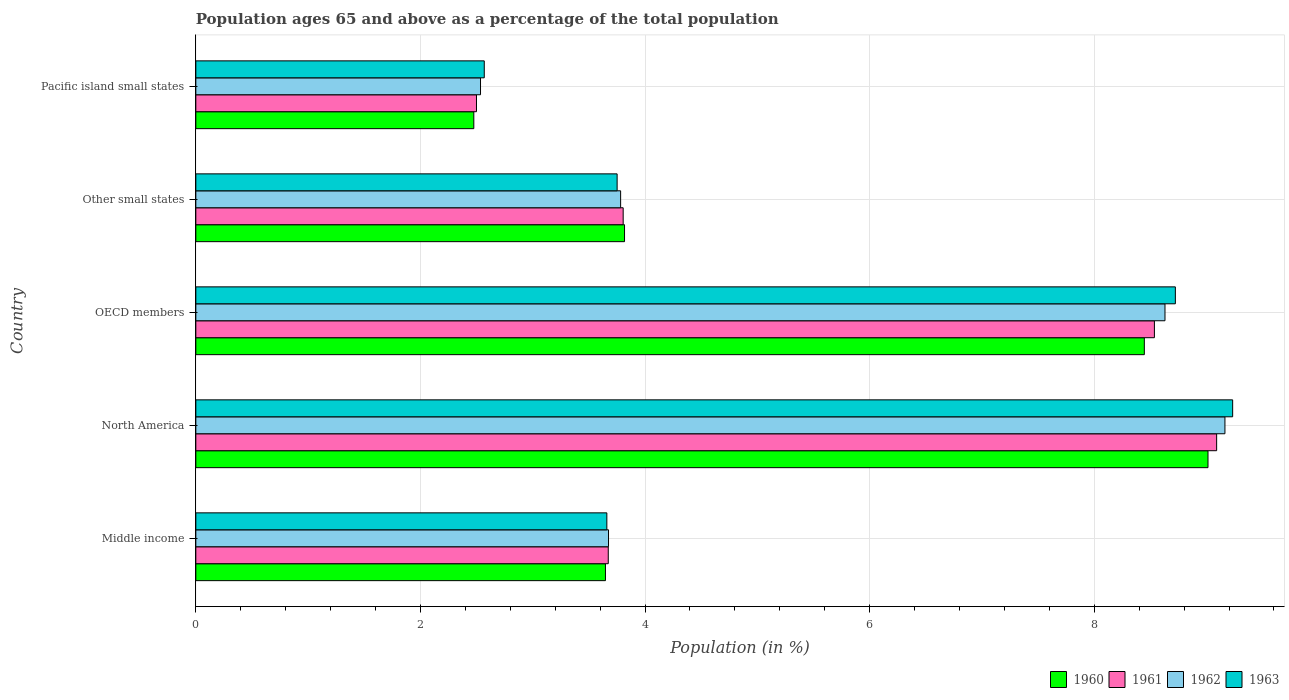How many different coloured bars are there?
Provide a short and direct response. 4. How many groups of bars are there?
Give a very brief answer. 5. How many bars are there on the 5th tick from the top?
Your answer should be compact. 4. What is the label of the 1st group of bars from the top?
Offer a very short reply. Pacific island small states. In how many cases, is the number of bars for a given country not equal to the number of legend labels?
Provide a succinct answer. 0. What is the percentage of the population ages 65 and above in 1962 in North America?
Your answer should be compact. 9.16. Across all countries, what is the maximum percentage of the population ages 65 and above in 1962?
Your answer should be compact. 9.16. Across all countries, what is the minimum percentage of the population ages 65 and above in 1963?
Offer a terse response. 2.57. In which country was the percentage of the population ages 65 and above in 1960 minimum?
Offer a terse response. Pacific island small states. What is the total percentage of the population ages 65 and above in 1961 in the graph?
Your answer should be compact. 27.6. What is the difference between the percentage of the population ages 65 and above in 1961 in Middle income and that in Pacific island small states?
Give a very brief answer. 1.17. What is the difference between the percentage of the population ages 65 and above in 1961 in Pacific island small states and the percentage of the population ages 65 and above in 1963 in Middle income?
Your answer should be compact. -1.16. What is the average percentage of the population ages 65 and above in 1962 per country?
Offer a very short reply. 5.56. What is the difference between the percentage of the population ages 65 and above in 1961 and percentage of the population ages 65 and above in 1960 in North America?
Your answer should be very brief. 0.08. In how many countries, is the percentage of the population ages 65 and above in 1962 greater than 8.4 ?
Provide a succinct answer. 2. What is the ratio of the percentage of the population ages 65 and above in 1961 in OECD members to that in Pacific island small states?
Offer a terse response. 3.42. Is the difference between the percentage of the population ages 65 and above in 1961 in OECD members and Pacific island small states greater than the difference between the percentage of the population ages 65 and above in 1960 in OECD members and Pacific island small states?
Ensure brevity in your answer.  Yes. What is the difference between the highest and the second highest percentage of the population ages 65 and above in 1962?
Ensure brevity in your answer.  0.53. What is the difference between the highest and the lowest percentage of the population ages 65 and above in 1961?
Make the answer very short. 6.59. In how many countries, is the percentage of the population ages 65 and above in 1960 greater than the average percentage of the population ages 65 and above in 1960 taken over all countries?
Offer a very short reply. 2. Is the sum of the percentage of the population ages 65 and above in 1960 in Middle income and North America greater than the maximum percentage of the population ages 65 and above in 1962 across all countries?
Provide a short and direct response. Yes. Does the graph contain any zero values?
Keep it short and to the point. No. How many legend labels are there?
Make the answer very short. 4. What is the title of the graph?
Offer a terse response. Population ages 65 and above as a percentage of the total population. What is the label or title of the Y-axis?
Your response must be concise. Country. What is the Population (in %) of 1960 in Middle income?
Make the answer very short. 3.65. What is the Population (in %) of 1961 in Middle income?
Provide a succinct answer. 3.67. What is the Population (in %) in 1962 in Middle income?
Offer a terse response. 3.67. What is the Population (in %) in 1963 in Middle income?
Make the answer very short. 3.66. What is the Population (in %) in 1960 in North America?
Your response must be concise. 9.01. What is the Population (in %) in 1961 in North America?
Provide a succinct answer. 9.09. What is the Population (in %) in 1962 in North America?
Ensure brevity in your answer.  9.16. What is the Population (in %) in 1963 in North America?
Offer a very short reply. 9.23. What is the Population (in %) of 1960 in OECD members?
Offer a terse response. 8.45. What is the Population (in %) in 1961 in OECD members?
Your answer should be very brief. 8.54. What is the Population (in %) in 1962 in OECD members?
Your response must be concise. 8.63. What is the Population (in %) in 1963 in OECD members?
Your answer should be very brief. 8.72. What is the Population (in %) of 1960 in Other small states?
Offer a very short reply. 3.82. What is the Population (in %) of 1961 in Other small states?
Your answer should be compact. 3.81. What is the Population (in %) of 1962 in Other small states?
Keep it short and to the point. 3.78. What is the Population (in %) in 1963 in Other small states?
Provide a succinct answer. 3.75. What is the Population (in %) of 1960 in Pacific island small states?
Make the answer very short. 2.48. What is the Population (in %) in 1961 in Pacific island small states?
Offer a terse response. 2.5. What is the Population (in %) of 1962 in Pacific island small states?
Make the answer very short. 2.54. What is the Population (in %) of 1963 in Pacific island small states?
Your answer should be very brief. 2.57. Across all countries, what is the maximum Population (in %) of 1960?
Offer a very short reply. 9.01. Across all countries, what is the maximum Population (in %) in 1961?
Keep it short and to the point. 9.09. Across all countries, what is the maximum Population (in %) of 1962?
Keep it short and to the point. 9.16. Across all countries, what is the maximum Population (in %) of 1963?
Give a very brief answer. 9.23. Across all countries, what is the minimum Population (in %) in 1960?
Make the answer very short. 2.48. Across all countries, what is the minimum Population (in %) in 1961?
Make the answer very short. 2.5. Across all countries, what is the minimum Population (in %) in 1962?
Ensure brevity in your answer.  2.54. Across all countries, what is the minimum Population (in %) in 1963?
Your response must be concise. 2.57. What is the total Population (in %) of 1960 in the graph?
Your answer should be compact. 27.4. What is the total Population (in %) in 1961 in the graph?
Provide a short and direct response. 27.6. What is the total Population (in %) in 1962 in the graph?
Provide a succinct answer. 27.79. What is the total Population (in %) in 1963 in the graph?
Provide a short and direct response. 27.93. What is the difference between the Population (in %) of 1960 in Middle income and that in North America?
Ensure brevity in your answer.  -5.37. What is the difference between the Population (in %) in 1961 in Middle income and that in North America?
Your answer should be very brief. -5.42. What is the difference between the Population (in %) in 1962 in Middle income and that in North America?
Provide a short and direct response. -5.49. What is the difference between the Population (in %) in 1963 in Middle income and that in North America?
Keep it short and to the point. -5.57. What is the difference between the Population (in %) of 1960 in Middle income and that in OECD members?
Your response must be concise. -4.8. What is the difference between the Population (in %) in 1961 in Middle income and that in OECD members?
Offer a terse response. -4.86. What is the difference between the Population (in %) in 1962 in Middle income and that in OECD members?
Your response must be concise. -4.96. What is the difference between the Population (in %) of 1963 in Middle income and that in OECD members?
Provide a short and direct response. -5.06. What is the difference between the Population (in %) in 1960 in Middle income and that in Other small states?
Your response must be concise. -0.17. What is the difference between the Population (in %) in 1961 in Middle income and that in Other small states?
Offer a very short reply. -0.13. What is the difference between the Population (in %) of 1962 in Middle income and that in Other small states?
Your response must be concise. -0.11. What is the difference between the Population (in %) of 1963 in Middle income and that in Other small states?
Your answer should be compact. -0.09. What is the difference between the Population (in %) in 1960 in Middle income and that in Pacific island small states?
Give a very brief answer. 1.17. What is the difference between the Population (in %) of 1961 in Middle income and that in Pacific island small states?
Provide a short and direct response. 1.17. What is the difference between the Population (in %) of 1962 in Middle income and that in Pacific island small states?
Offer a very short reply. 1.14. What is the difference between the Population (in %) of 1963 in Middle income and that in Pacific island small states?
Make the answer very short. 1.09. What is the difference between the Population (in %) of 1960 in North America and that in OECD members?
Ensure brevity in your answer.  0.57. What is the difference between the Population (in %) of 1961 in North America and that in OECD members?
Offer a very short reply. 0.55. What is the difference between the Population (in %) of 1962 in North America and that in OECD members?
Give a very brief answer. 0.53. What is the difference between the Population (in %) in 1963 in North America and that in OECD members?
Your answer should be very brief. 0.51. What is the difference between the Population (in %) in 1960 in North America and that in Other small states?
Give a very brief answer. 5.2. What is the difference between the Population (in %) of 1961 in North America and that in Other small states?
Your answer should be compact. 5.28. What is the difference between the Population (in %) in 1962 in North America and that in Other small states?
Provide a succinct answer. 5.38. What is the difference between the Population (in %) in 1963 in North America and that in Other small states?
Ensure brevity in your answer.  5.48. What is the difference between the Population (in %) in 1960 in North America and that in Pacific island small states?
Provide a short and direct response. 6.54. What is the difference between the Population (in %) of 1961 in North America and that in Pacific island small states?
Make the answer very short. 6.59. What is the difference between the Population (in %) of 1962 in North America and that in Pacific island small states?
Provide a succinct answer. 6.63. What is the difference between the Population (in %) in 1963 in North America and that in Pacific island small states?
Your answer should be very brief. 6.66. What is the difference between the Population (in %) in 1960 in OECD members and that in Other small states?
Keep it short and to the point. 4.63. What is the difference between the Population (in %) in 1961 in OECD members and that in Other small states?
Make the answer very short. 4.73. What is the difference between the Population (in %) of 1962 in OECD members and that in Other small states?
Make the answer very short. 4.85. What is the difference between the Population (in %) of 1963 in OECD members and that in Other small states?
Provide a short and direct response. 4.97. What is the difference between the Population (in %) in 1960 in OECD members and that in Pacific island small states?
Your response must be concise. 5.97. What is the difference between the Population (in %) of 1961 in OECD members and that in Pacific island small states?
Ensure brevity in your answer.  6.04. What is the difference between the Population (in %) in 1962 in OECD members and that in Pacific island small states?
Your answer should be very brief. 6.09. What is the difference between the Population (in %) in 1963 in OECD members and that in Pacific island small states?
Make the answer very short. 6.15. What is the difference between the Population (in %) in 1960 in Other small states and that in Pacific island small states?
Keep it short and to the point. 1.34. What is the difference between the Population (in %) of 1961 in Other small states and that in Pacific island small states?
Provide a succinct answer. 1.31. What is the difference between the Population (in %) of 1962 in Other small states and that in Pacific island small states?
Keep it short and to the point. 1.25. What is the difference between the Population (in %) in 1963 in Other small states and that in Pacific island small states?
Ensure brevity in your answer.  1.18. What is the difference between the Population (in %) in 1960 in Middle income and the Population (in %) in 1961 in North America?
Keep it short and to the point. -5.44. What is the difference between the Population (in %) of 1960 in Middle income and the Population (in %) of 1962 in North America?
Keep it short and to the point. -5.52. What is the difference between the Population (in %) of 1960 in Middle income and the Population (in %) of 1963 in North America?
Your response must be concise. -5.58. What is the difference between the Population (in %) in 1961 in Middle income and the Population (in %) in 1962 in North America?
Provide a succinct answer. -5.49. What is the difference between the Population (in %) of 1961 in Middle income and the Population (in %) of 1963 in North America?
Your answer should be compact. -5.56. What is the difference between the Population (in %) of 1962 in Middle income and the Population (in %) of 1963 in North America?
Your answer should be compact. -5.56. What is the difference between the Population (in %) of 1960 in Middle income and the Population (in %) of 1961 in OECD members?
Ensure brevity in your answer.  -4.89. What is the difference between the Population (in %) of 1960 in Middle income and the Population (in %) of 1962 in OECD members?
Give a very brief answer. -4.98. What is the difference between the Population (in %) of 1960 in Middle income and the Population (in %) of 1963 in OECD members?
Offer a terse response. -5.07. What is the difference between the Population (in %) of 1961 in Middle income and the Population (in %) of 1962 in OECD members?
Your answer should be compact. -4.96. What is the difference between the Population (in %) in 1961 in Middle income and the Population (in %) in 1963 in OECD members?
Offer a terse response. -5.05. What is the difference between the Population (in %) of 1962 in Middle income and the Population (in %) of 1963 in OECD members?
Provide a short and direct response. -5.05. What is the difference between the Population (in %) of 1960 in Middle income and the Population (in %) of 1961 in Other small states?
Your answer should be compact. -0.16. What is the difference between the Population (in %) in 1960 in Middle income and the Population (in %) in 1962 in Other small states?
Provide a short and direct response. -0.14. What is the difference between the Population (in %) in 1960 in Middle income and the Population (in %) in 1963 in Other small states?
Offer a very short reply. -0.1. What is the difference between the Population (in %) in 1961 in Middle income and the Population (in %) in 1962 in Other small states?
Offer a terse response. -0.11. What is the difference between the Population (in %) in 1961 in Middle income and the Population (in %) in 1963 in Other small states?
Provide a short and direct response. -0.08. What is the difference between the Population (in %) of 1962 in Middle income and the Population (in %) of 1963 in Other small states?
Your answer should be compact. -0.08. What is the difference between the Population (in %) in 1960 in Middle income and the Population (in %) in 1961 in Pacific island small states?
Make the answer very short. 1.15. What is the difference between the Population (in %) in 1960 in Middle income and the Population (in %) in 1962 in Pacific island small states?
Your answer should be very brief. 1.11. What is the difference between the Population (in %) of 1960 in Middle income and the Population (in %) of 1963 in Pacific island small states?
Ensure brevity in your answer.  1.08. What is the difference between the Population (in %) of 1961 in Middle income and the Population (in %) of 1962 in Pacific island small states?
Offer a very short reply. 1.14. What is the difference between the Population (in %) of 1961 in Middle income and the Population (in %) of 1963 in Pacific island small states?
Provide a succinct answer. 1.1. What is the difference between the Population (in %) in 1962 in Middle income and the Population (in %) in 1963 in Pacific island small states?
Your answer should be compact. 1.11. What is the difference between the Population (in %) of 1960 in North America and the Population (in %) of 1961 in OECD members?
Ensure brevity in your answer.  0.48. What is the difference between the Population (in %) of 1960 in North America and the Population (in %) of 1962 in OECD members?
Your response must be concise. 0.38. What is the difference between the Population (in %) in 1960 in North America and the Population (in %) in 1963 in OECD members?
Your answer should be very brief. 0.29. What is the difference between the Population (in %) in 1961 in North America and the Population (in %) in 1962 in OECD members?
Provide a succinct answer. 0.46. What is the difference between the Population (in %) in 1961 in North America and the Population (in %) in 1963 in OECD members?
Offer a very short reply. 0.37. What is the difference between the Population (in %) in 1962 in North America and the Population (in %) in 1963 in OECD members?
Your answer should be compact. 0.44. What is the difference between the Population (in %) in 1960 in North America and the Population (in %) in 1961 in Other small states?
Give a very brief answer. 5.21. What is the difference between the Population (in %) in 1960 in North America and the Population (in %) in 1962 in Other small states?
Offer a terse response. 5.23. What is the difference between the Population (in %) of 1960 in North America and the Population (in %) of 1963 in Other small states?
Keep it short and to the point. 5.26. What is the difference between the Population (in %) in 1961 in North America and the Population (in %) in 1962 in Other small states?
Make the answer very short. 5.31. What is the difference between the Population (in %) of 1961 in North America and the Population (in %) of 1963 in Other small states?
Give a very brief answer. 5.34. What is the difference between the Population (in %) in 1962 in North America and the Population (in %) in 1963 in Other small states?
Your answer should be very brief. 5.41. What is the difference between the Population (in %) in 1960 in North America and the Population (in %) in 1961 in Pacific island small states?
Keep it short and to the point. 6.51. What is the difference between the Population (in %) in 1960 in North America and the Population (in %) in 1962 in Pacific island small states?
Your answer should be compact. 6.48. What is the difference between the Population (in %) of 1960 in North America and the Population (in %) of 1963 in Pacific island small states?
Provide a short and direct response. 6.44. What is the difference between the Population (in %) in 1961 in North America and the Population (in %) in 1962 in Pacific island small states?
Keep it short and to the point. 6.55. What is the difference between the Population (in %) in 1961 in North America and the Population (in %) in 1963 in Pacific island small states?
Provide a succinct answer. 6.52. What is the difference between the Population (in %) in 1962 in North America and the Population (in %) in 1963 in Pacific island small states?
Provide a short and direct response. 6.6. What is the difference between the Population (in %) of 1960 in OECD members and the Population (in %) of 1961 in Other small states?
Give a very brief answer. 4.64. What is the difference between the Population (in %) of 1960 in OECD members and the Population (in %) of 1962 in Other small states?
Keep it short and to the point. 4.66. What is the difference between the Population (in %) of 1960 in OECD members and the Population (in %) of 1963 in Other small states?
Offer a very short reply. 4.69. What is the difference between the Population (in %) of 1961 in OECD members and the Population (in %) of 1962 in Other small states?
Your response must be concise. 4.75. What is the difference between the Population (in %) of 1961 in OECD members and the Population (in %) of 1963 in Other small states?
Provide a short and direct response. 4.78. What is the difference between the Population (in %) in 1962 in OECD members and the Population (in %) in 1963 in Other small states?
Make the answer very short. 4.88. What is the difference between the Population (in %) in 1960 in OECD members and the Population (in %) in 1961 in Pacific island small states?
Offer a very short reply. 5.95. What is the difference between the Population (in %) in 1960 in OECD members and the Population (in %) in 1962 in Pacific island small states?
Your response must be concise. 5.91. What is the difference between the Population (in %) of 1960 in OECD members and the Population (in %) of 1963 in Pacific island small states?
Ensure brevity in your answer.  5.88. What is the difference between the Population (in %) in 1961 in OECD members and the Population (in %) in 1962 in Pacific island small states?
Provide a short and direct response. 6. What is the difference between the Population (in %) of 1961 in OECD members and the Population (in %) of 1963 in Pacific island small states?
Offer a terse response. 5.97. What is the difference between the Population (in %) in 1962 in OECD members and the Population (in %) in 1963 in Pacific island small states?
Your answer should be very brief. 6.06. What is the difference between the Population (in %) in 1960 in Other small states and the Population (in %) in 1961 in Pacific island small states?
Offer a terse response. 1.32. What is the difference between the Population (in %) of 1960 in Other small states and the Population (in %) of 1962 in Pacific island small states?
Ensure brevity in your answer.  1.28. What is the difference between the Population (in %) in 1960 in Other small states and the Population (in %) in 1963 in Pacific island small states?
Offer a very short reply. 1.25. What is the difference between the Population (in %) in 1961 in Other small states and the Population (in %) in 1962 in Pacific island small states?
Make the answer very short. 1.27. What is the difference between the Population (in %) in 1961 in Other small states and the Population (in %) in 1963 in Pacific island small states?
Offer a very short reply. 1.24. What is the difference between the Population (in %) in 1962 in Other small states and the Population (in %) in 1963 in Pacific island small states?
Ensure brevity in your answer.  1.21. What is the average Population (in %) of 1960 per country?
Provide a succinct answer. 5.48. What is the average Population (in %) of 1961 per country?
Keep it short and to the point. 5.52. What is the average Population (in %) of 1962 per country?
Your answer should be compact. 5.56. What is the average Population (in %) in 1963 per country?
Provide a succinct answer. 5.59. What is the difference between the Population (in %) of 1960 and Population (in %) of 1961 in Middle income?
Make the answer very short. -0.03. What is the difference between the Population (in %) of 1960 and Population (in %) of 1962 in Middle income?
Offer a terse response. -0.03. What is the difference between the Population (in %) in 1960 and Population (in %) in 1963 in Middle income?
Ensure brevity in your answer.  -0.01. What is the difference between the Population (in %) in 1961 and Population (in %) in 1962 in Middle income?
Offer a very short reply. -0. What is the difference between the Population (in %) in 1961 and Population (in %) in 1963 in Middle income?
Your response must be concise. 0.01. What is the difference between the Population (in %) in 1962 and Population (in %) in 1963 in Middle income?
Give a very brief answer. 0.01. What is the difference between the Population (in %) in 1960 and Population (in %) in 1961 in North America?
Give a very brief answer. -0.08. What is the difference between the Population (in %) of 1960 and Population (in %) of 1962 in North America?
Make the answer very short. -0.15. What is the difference between the Population (in %) in 1960 and Population (in %) in 1963 in North America?
Make the answer very short. -0.22. What is the difference between the Population (in %) of 1961 and Population (in %) of 1962 in North America?
Offer a very short reply. -0.07. What is the difference between the Population (in %) in 1961 and Population (in %) in 1963 in North America?
Give a very brief answer. -0.14. What is the difference between the Population (in %) of 1962 and Population (in %) of 1963 in North America?
Provide a succinct answer. -0.07. What is the difference between the Population (in %) of 1960 and Population (in %) of 1961 in OECD members?
Your answer should be very brief. -0.09. What is the difference between the Population (in %) in 1960 and Population (in %) in 1962 in OECD members?
Make the answer very short. -0.18. What is the difference between the Population (in %) of 1960 and Population (in %) of 1963 in OECD members?
Provide a short and direct response. -0.28. What is the difference between the Population (in %) of 1961 and Population (in %) of 1962 in OECD members?
Your answer should be compact. -0.09. What is the difference between the Population (in %) in 1961 and Population (in %) in 1963 in OECD members?
Make the answer very short. -0.19. What is the difference between the Population (in %) in 1962 and Population (in %) in 1963 in OECD members?
Provide a short and direct response. -0.09. What is the difference between the Population (in %) of 1960 and Population (in %) of 1961 in Other small states?
Keep it short and to the point. 0.01. What is the difference between the Population (in %) in 1960 and Population (in %) in 1962 in Other small states?
Keep it short and to the point. 0.03. What is the difference between the Population (in %) of 1960 and Population (in %) of 1963 in Other small states?
Your answer should be compact. 0.07. What is the difference between the Population (in %) of 1961 and Population (in %) of 1962 in Other small states?
Make the answer very short. 0.02. What is the difference between the Population (in %) in 1961 and Population (in %) in 1963 in Other small states?
Your answer should be very brief. 0.05. What is the difference between the Population (in %) in 1962 and Population (in %) in 1963 in Other small states?
Give a very brief answer. 0.03. What is the difference between the Population (in %) in 1960 and Population (in %) in 1961 in Pacific island small states?
Provide a succinct answer. -0.02. What is the difference between the Population (in %) of 1960 and Population (in %) of 1962 in Pacific island small states?
Offer a terse response. -0.06. What is the difference between the Population (in %) in 1960 and Population (in %) in 1963 in Pacific island small states?
Your response must be concise. -0.09. What is the difference between the Population (in %) in 1961 and Population (in %) in 1962 in Pacific island small states?
Keep it short and to the point. -0.04. What is the difference between the Population (in %) of 1961 and Population (in %) of 1963 in Pacific island small states?
Provide a short and direct response. -0.07. What is the difference between the Population (in %) in 1962 and Population (in %) in 1963 in Pacific island small states?
Make the answer very short. -0.03. What is the ratio of the Population (in %) in 1960 in Middle income to that in North America?
Provide a succinct answer. 0.4. What is the ratio of the Population (in %) in 1961 in Middle income to that in North America?
Make the answer very short. 0.4. What is the ratio of the Population (in %) in 1962 in Middle income to that in North America?
Provide a short and direct response. 0.4. What is the ratio of the Population (in %) of 1963 in Middle income to that in North America?
Offer a terse response. 0.4. What is the ratio of the Population (in %) in 1960 in Middle income to that in OECD members?
Provide a succinct answer. 0.43. What is the ratio of the Population (in %) of 1961 in Middle income to that in OECD members?
Your answer should be compact. 0.43. What is the ratio of the Population (in %) in 1962 in Middle income to that in OECD members?
Provide a succinct answer. 0.43. What is the ratio of the Population (in %) of 1963 in Middle income to that in OECD members?
Your answer should be very brief. 0.42. What is the ratio of the Population (in %) in 1960 in Middle income to that in Other small states?
Offer a terse response. 0.96. What is the ratio of the Population (in %) in 1961 in Middle income to that in Other small states?
Keep it short and to the point. 0.97. What is the ratio of the Population (in %) in 1962 in Middle income to that in Other small states?
Provide a succinct answer. 0.97. What is the ratio of the Population (in %) in 1963 in Middle income to that in Other small states?
Ensure brevity in your answer.  0.98. What is the ratio of the Population (in %) of 1960 in Middle income to that in Pacific island small states?
Ensure brevity in your answer.  1.47. What is the ratio of the Population (in %) in 1961 in Middle income to that in Pacific island small states?
Give a very brief answer. 1.47. What is the ratio of the Population (in %) in 1962 in Middle income to that in Pacific island small states?
Your response must be concise. 1.45. What is the ratio of the Population (in %) in 1963 in Middle income to that in Pacific island small states?
Your response must be concise. 1.43. What is the ratio of the Population (in %) of 1960 in North America to that in OECD members?
Offer a terse response. 1.07. What is the ratio of the Population (in %) in 1961 in North America to that in OECD members?
Ensure brevity in your answer.  1.06. What is the ratio of the Population (in %) of 1962 in North America to that in OECD members?
Offer a very short reply. 1.06. What is the ratio of the Population (in %) in 1963 in North America to that in OECD members?
Your response must be concise. 1.06. What is the ratio of the Population (in %) of 1960 in North America to that in Other small states?
Keep it short and to the point. 2.36. What is the ratio of the Population (in %) of 1961 in North America to that in Other small states?
Your answer should be very brief. 2.39. What is the ratio of the Population (in %) of 1962 in North America to that in Other small states?
Your answer should be compact. 2.42. What is the ratio of the Population (in %) in 1963 in North America to that in Other small states?
Provide a short and direct response. 2.46. What is the ratio of the Population (in %) of 1960 in North America to that in Pacific island small states?
Offer a terse response. 3.64. What is the ratio of the Population (in %) of 1961 in North America to that in Pacific island small states?
Make the answer very short. 3.64. What is the ratio of the Population (in %) of 1962 in North America to that in Pacific island small states?
Offer a very short reply. 3.61. What is the ratio of the Population (in %) in 1963 in North America to that in Pacific island small states?
Provide a succinct answer. 3.59. What is the ratio of the Population (in %) of 1960 in OECD members to that in Other small states?
Ensure brevity in your answer.  2.21. What is the ratio of the Population (in %) in 1961 in OECD members to that in Other small states?
Offer a very short reply. 2.24. What is the ratio of the Population (in %) of 1962 in OECD members to that in Other small states?
Offer a terse response. 2.28. What is the ratio of the Population (in %) in 1963 in OECD members to that in Other small states?
Make the answer very short. 2.33. What is the ratio of the Population (in %) of 1960 in OECD members to that in Pacific island small states?
Give a very brief answer. 3.41. What is the ratio of the Population (in %) in 1961 in OECD members to that in Pacific island small states?
Give a very brief answer. 3.42. What is the ratio of the Population (in %) of 1962 in OECD members to that in Pacific island small states?
Your response must be concise. 3.4. What is the ratio of the Population (in %) in 1963 in OECD members to that in Pacific island small states?
Your answer should be very brief. 3.4. What is the ratio of the Population (in %) of 1960 in Other small states to that in Pacific island small states?
Offer a very short reply. 1.54. What is the ratio of the Population (in %) of 1961 in Other small states to that in Pacific island small states?
Provide a short and direct response. 1.52. What is the ratio of the Population (in %) in 1962 in Other small states to that in Pacific island small states?
Your answer should be compact. 1.49. What is the ratio of the Population (in %) in 1963 in Other small states to that in Pacific island small states?
Your answer should be very brief. 1.46. What is the difference between the highest and the second highest Population (in %) in 1960?
Make the answer very short. 0.57. What is the difference between the highest and the second highest Population (in %) in 1961?
Offer a very short reply. 0.55. What is the difference between the highest and the second highest Population (in %) of 1962?
Provide a succinct answer. 0.53. What is the difference between the highest and the second highest Population (in %) in 1963?
Your answer should be very brief. 0.51. What is the difference between the highest and the lowest Population (in %) in 1960?
Ensure brevity in your answer.  6.54. What is the difference between the highest and the lowest Population (in %) in 1961?
Your answer should be compact. 6.59. What is the difference between the highest and the lowest Population (in %) of 1962?
Your answer should be very brief. 6.63. What is the difference between the highest and the lowest Population (in %) in 1963?
Your answer should be compact. 6.66. 